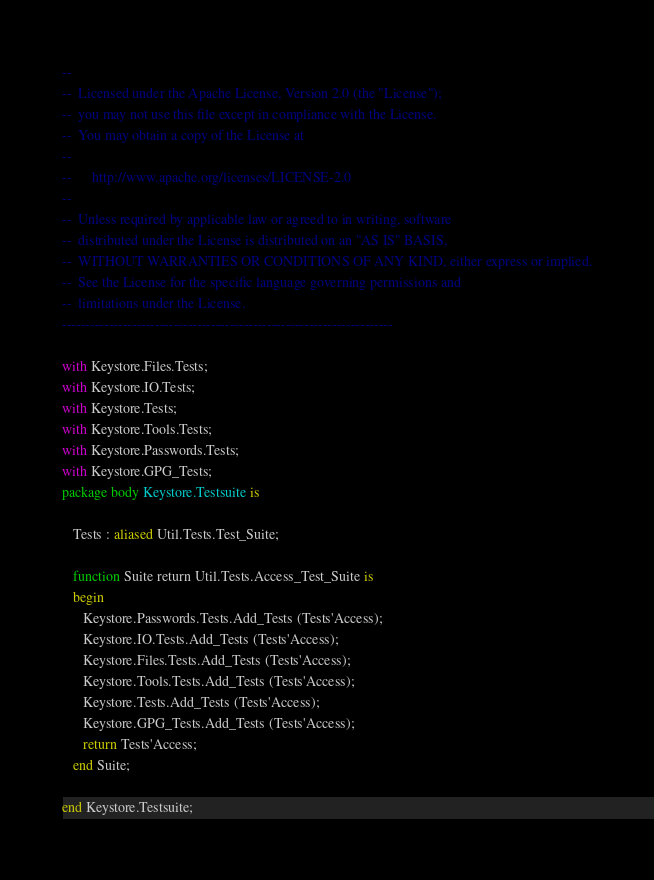<code> <loc_0><loc_0><loc_500><loc_500><_Ada_>--
--  Licensed under the Apache License, Version 2.0 (the "License");
--  you may not use this file except in compliance with the License.
--  You may obtain a copy of the License at
--
--      http://www.apache.org/licenses/LICENSE-2.0
--
--  Unless required by applicable law or agreed to in writing, software
--  distributed under the License is distributed on an "AS IS" BASIS,
--  WITHOUT WARRANTIES OR CONDITIONS OF ANY KIND, either express or implied.
--  See the License for the specific language governing permissions and
--  limitations under the License.
-----------------------------------------------------------------------

with Keystore.Files.Tests;
with Keystore.IO.Tests;
with Keystore.Tests;
with Keystore.Tools.Tests;
with Keystore.Passwords.Tests;
with Keystore.GPG_Tests;
package body Keystore.Testsuite is

   Tests : aliased Util.Tests.Test_Suite;

   function Suite return Util.Tests.Access_Test_Suite is
   begin
      Keystore.Passwords.Tests.Add_Tests (Tests'Access);
      Keystore.IO.Tests.Add_Tests (Tests'Access);
      Keystore.Files.Tests.Add_Tests (Tests'Access);
      Keystore.Tools.Tests.Add_Tests (Tests'Access);
      Keystore.Tests.Add_Tests (Tests'Access);
      Keystore.GPG_Tests.Add_Tests (Tests'Access);
      return Tests'Access;
   end Suite;

end Keystore.Testsuite;
</code> 